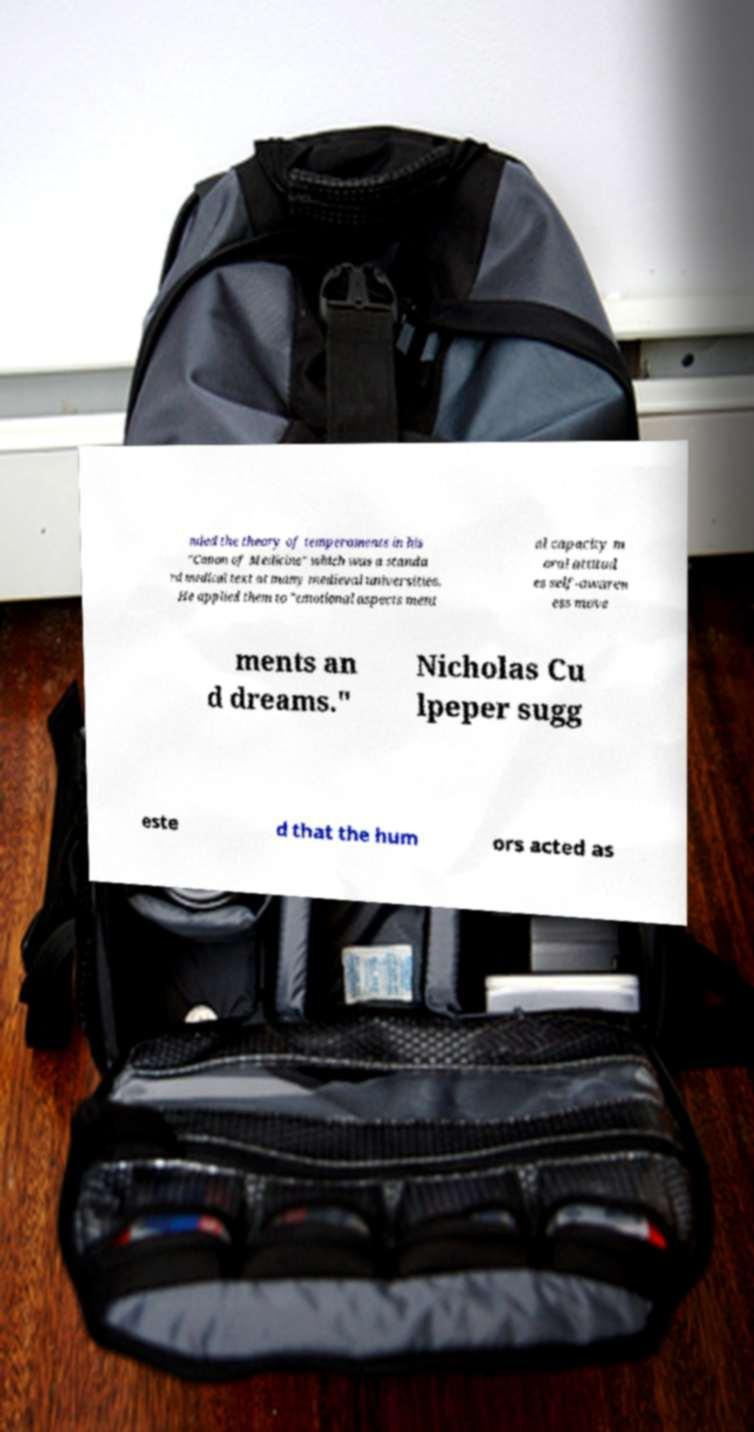Can you accurately transcribe the text from the provided image for me? nded the theory of temperaments in his "Canon of Medicine" which was a standa rd medical text at many medieval universities. He applied them to "emotional aspects ment al capacity m oral attitud es self-awaren ess move ments an d dreams." Nicholas Cu lpeper sugg este d that the hum ors acted as 